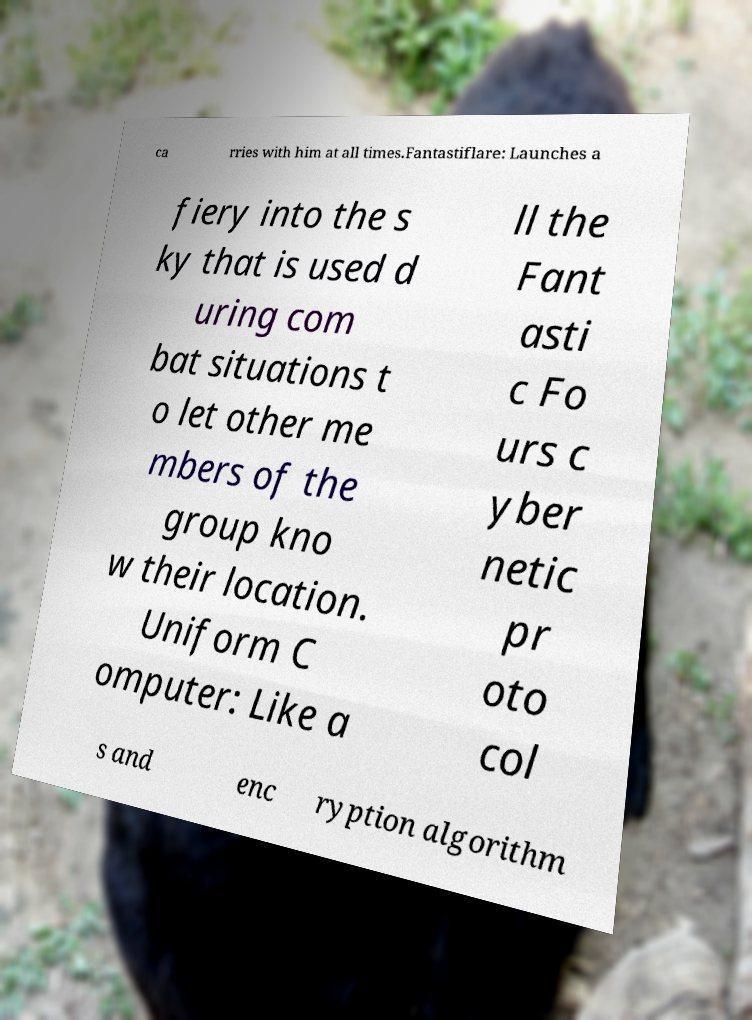What messages or text are displayed in this image? I need them in a readable, typed format. ca rries with him at all times.Fantastiflare: Launches a fiery into the s ky that is used d uring com bat situations t o let other me mbers of the group kno w their location. Uniform C omputer: Like a ll the Fant asti c Fo urs c yber netic pr oto col s and enc ryption algorithm 